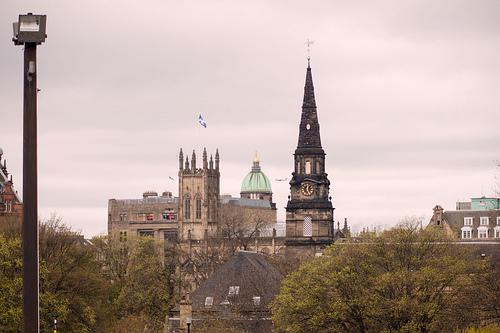Question: when is it?
Choices:
A. Night time.
B. Breakfast Time.
C. Lunch Time.
D. Day time.
Answer with the letter. Answer: D Question: what is in the sky?
Choices:
A. Sun.
B. Stars.
C. Airplane.
D. Clouds.
Answer with the letter. Answer: D Question: where are the clouds?
Choices:
A. In the background.
B. Sky.
C. Near the waterfall.
D. Far out to sea.
Answer with the letter. Answer: B Question: what is the building behind?
Choices:
A. Trees.
B. Fence.
C. Wall.
D. Parked cars.
Answer with the letter. Answer: A 